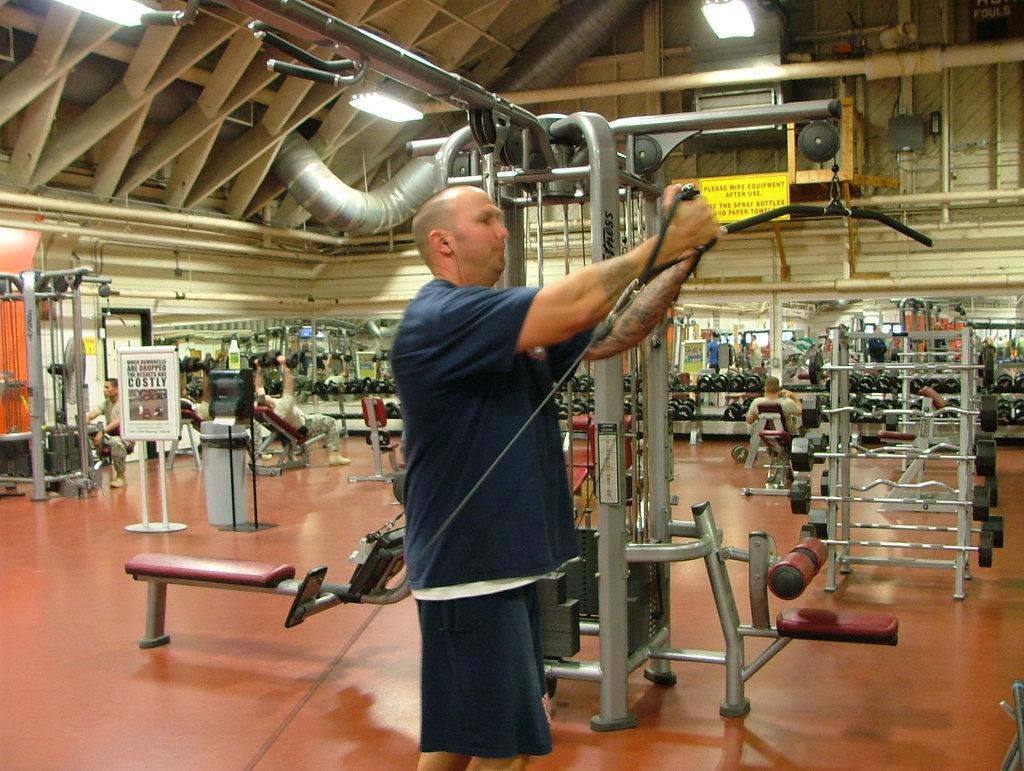Describe this image in one or two sentences. In this image we can see a person holding a gym equipment. In the back there are many gym equipment. Also there are few people. On the ceiling there are lights. 